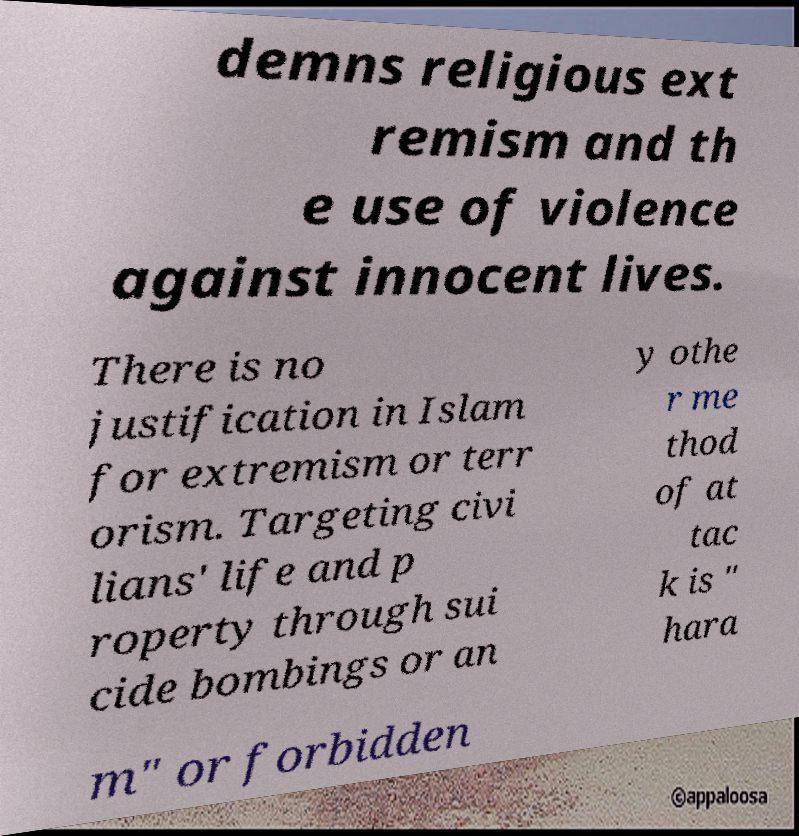I need the written content from this picture converted into text. Can you do that? demns religious ext remism and th e use of violence against innocent lives. There is no justification in Islam for extremism or terr orism. Targeting civi lians' life and p roperty through sui cide bombings or an y othe r me thod of at tac k is " hara m" or forbidden 